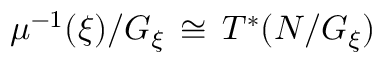Convert formula to latex. <formula><loc_0><loc_0><loc_500><loc_500>\mu ^ { - 1 } ( \xi ) / G _ { \xi } \, \cong \, T ^ { * } ( N / G _ { \xi } )</formula> 